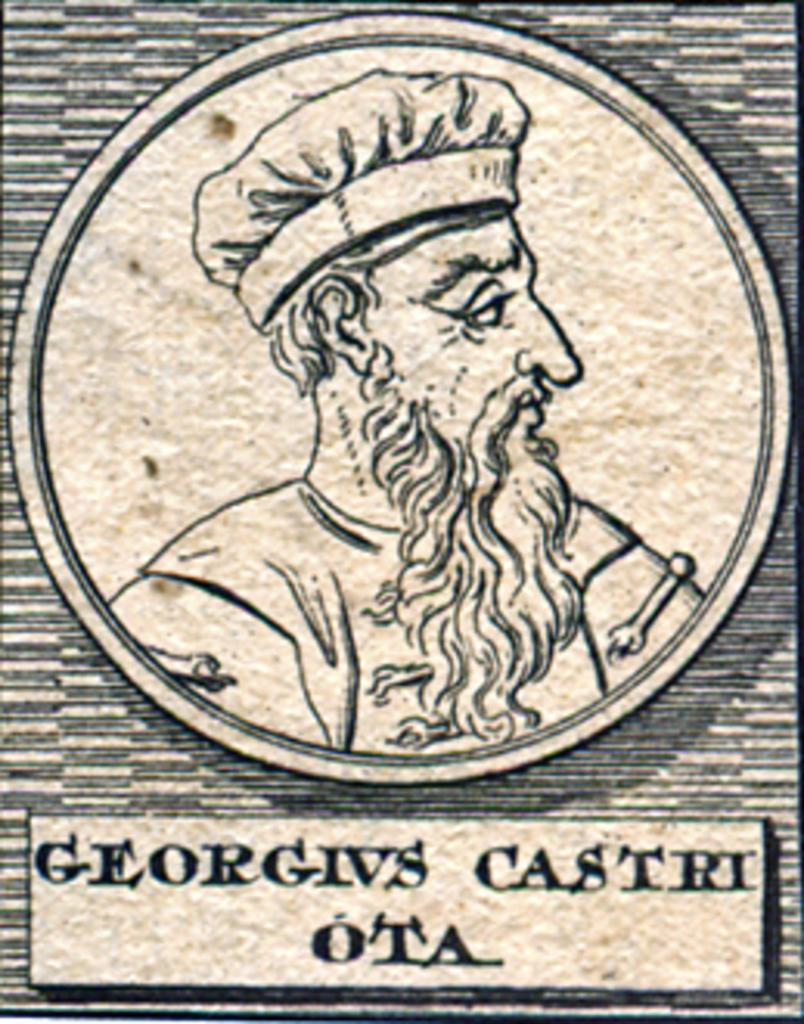What is the main subject of the painting? The painting depicts a man wearing a cap. Can you describe any additional details about the man in the painting? Unfortunately, the provided facts do not mention any other details about the man. What is written at the bottom of the painting? There is text written at the bottom of the painting. What is the man discussing with the other person in the painting? There is no other person present in the painting, as it only depicts a man wearing a cap. 